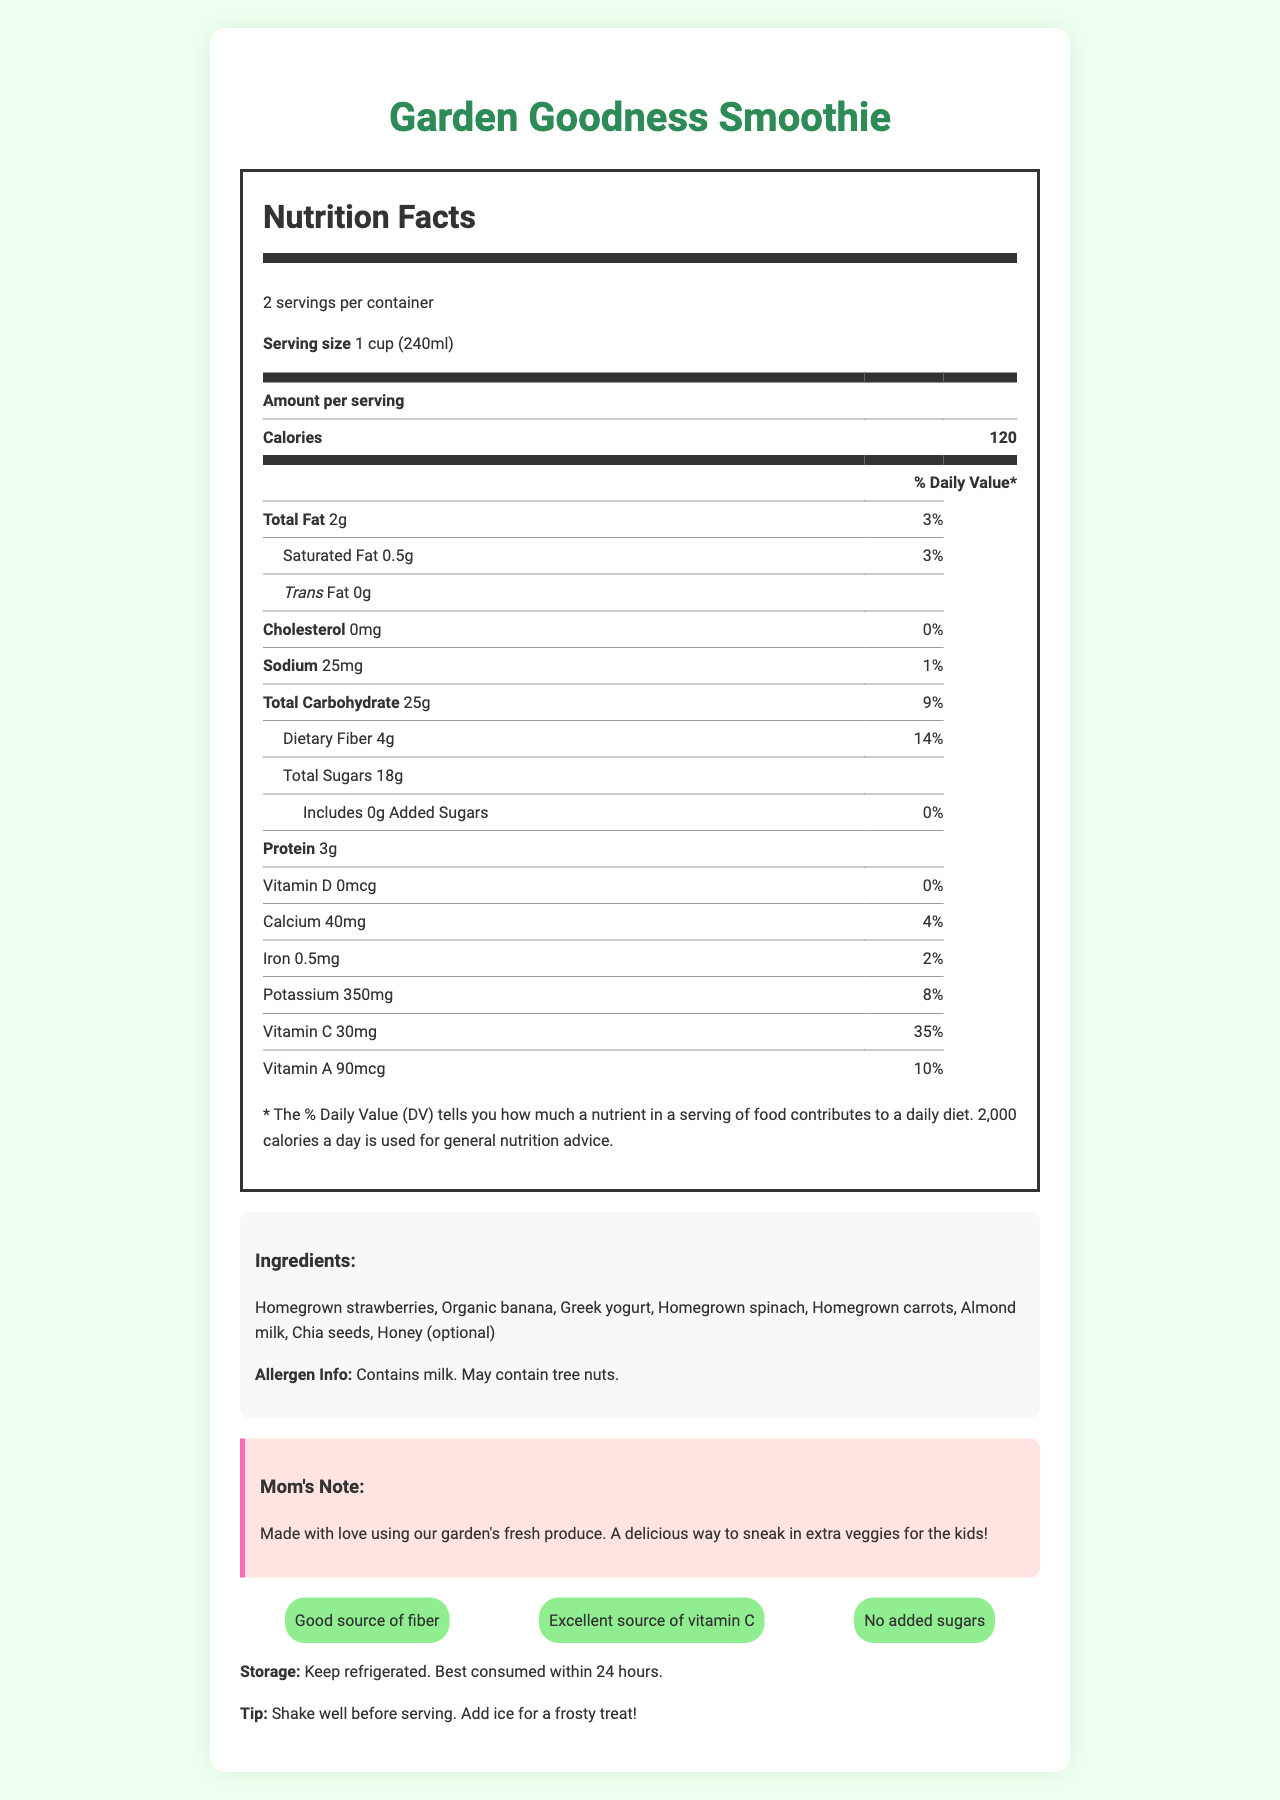what is the serving size for the Garden Goodness Smoothie? The serving size is explicitly stated as "1 cup (240ml)" on the Nutrition Facts label.
Answer: 1 cup (240ml) how many servings are there per container? The number of servings per container is mentioned as "2".
Answer: 2 how many grams of dietary fiber are in one serving? The dietary fiber content per serving is mentioned as "4g" in the Nutrition Facts section.
Answer: 4g how much Vitamin C does one serving of the smoothie provide? The Vitamin C content per serving is listed as "30mg".
Answer: 30mg how many calories are in one cup of the smoothie? The calorie count per serving is stated as "120".
Answer: 120 What is the total fat content per serving? The total fat amount per serving is given as "2g".
Answer: 2g how much protein is in one serving? The protein content per serving is listed as "3g" on the Nutrition Facts label.
Answer: 3g what is the daily value percentage of potassium in one serving? The daily value percentage for potassium is shown as "8%".
Answer: 8% What ingredients are featured in the Garden Goodness Smoothie? The list of ingredients is mentioned in the section beneath the Nutrition Facts label.
Answer: Homegrown strawberries, Organic banana, Greek yogurt, Homegrown spinach, Homegrown carrots, Almond milk, Chia seeds, Honey (optional) What is the intended storage method for the smoothie? The storage instructions are mentioned at the end of the document.
Answer: Keep refrigerated. Best consumed within 24 hours. does the smoothie contain any added sugars? The label explicitly states "No added sugars".
Answer: No Which of the following is a health claim made for the smoothie? A. Low in sodium B. High in protein C. Excellent source of vitamin C D. Contains caffeine The health claims mentioned include "Excellent source of vitamin C."
Answer: C What allergen is noted in the document? A. Gluten B. Shellfish C. Milk D. Soy The allergen information specifies that the smoothie "Contains milk."
Answer: C How much calcium does a serving of the smoothie provide? The calcium content per serving is listed as "40mg."
Answer: 40mg Is the smoothie considered a good source of fiber? The label includes "Good source of fiber" as one of its health claims.
Answer: Yes Does the smoothie contain any trans fat? The label indicates "0g" for trans fat.
Answer: No Summarize the main idea of the document. The document provides detailed nutritional information about the Garden Goodness Smoothie along with its ingredients, allergen info, health claims, and storage instructions.
Answer: The Garden Goodness Smoothie is a nutritious, kid-friendly beverage made from garden fruits and hidden vegetables, providing a good source of fiber and an excellent source of vitamin C, with no added sugars. It contains ingredients that are homegrown and organic and has specific storage and allergen information. What does the smoothie taste like? The document does not provide a detailed description of the smoothie’s taste.
Answer: Not enough information 